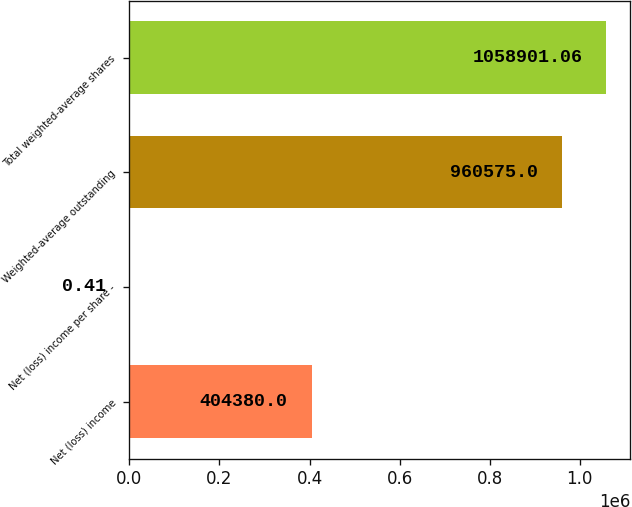Convert chart to OTSL. <chart><loc_0><loc_0><loc_500><loc_500><bar_chart><fcel>Net (loss) income<fcel>Net (loss) income per share -<fcel>Weighted-average outstanding<fcel>Total weighted-average shares<nl><fcel>404380<fcel>0.41<fcel>960575<fcel>1.0589e+06<nl></chart> 